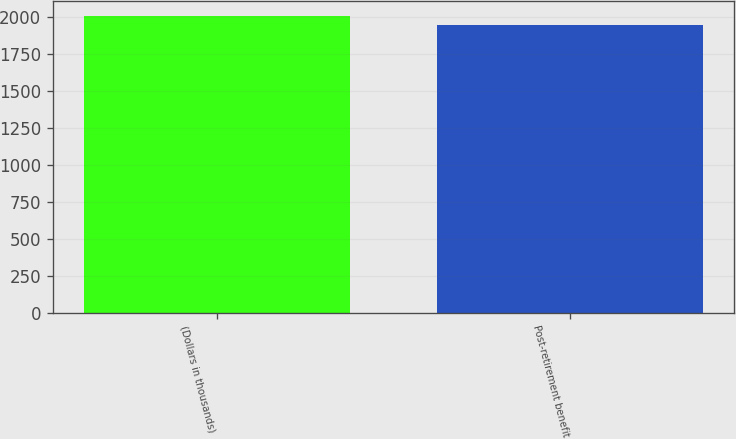Convert chart to OTSL. <chart><loc_0><loc_0><loc_500><loc_500><bar_chart><fcel>(Dollars in thousands)<fcel>Post-retirement benefit<nl><fcel>2010<fcel>1947<nl></chart> 